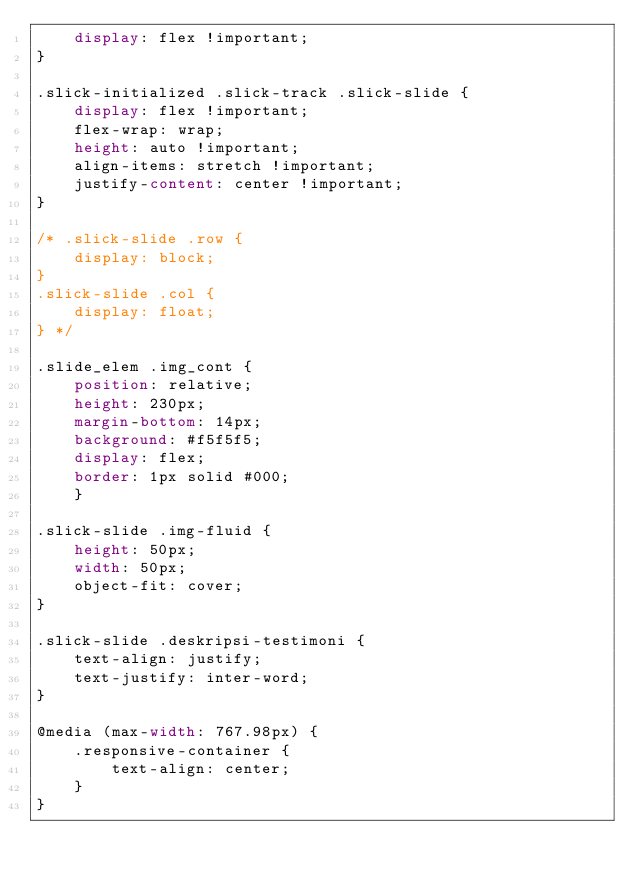Convert code to text. <code><loc_0><loc_0><loc_500><loc_500><_CSS_>    display: flex !important;
}

.slick-initialized .slick-track .slick-slide {
    display: flex !important;
    flex-wrap: wrap;
    height: auto !important;
    align-items: stretch !important;
    justify-content: center !important;
}

/* .slick-slide .row {
    display: block;
}
.slick-slide .col {
    display: float;
} */

.slide_elem .img_cont {
    position: relative;
    height: 230px;
    margin-bottom: 14px;
    background: #f5f5f5;
    display: flex;
    border: 1px solid #000;
    }

.slick-slide .img-fluid {
    height: 50px;
    width: 50px;
    object-fit: cover;
}

.slick-slide .deskripsi-testimoni {
    text-align: justify;
    text-justify: inter-word;
}

@media (max-width: 767.98px) {
    .responsive-container {
        text-align: center;
    }
}
</code> 